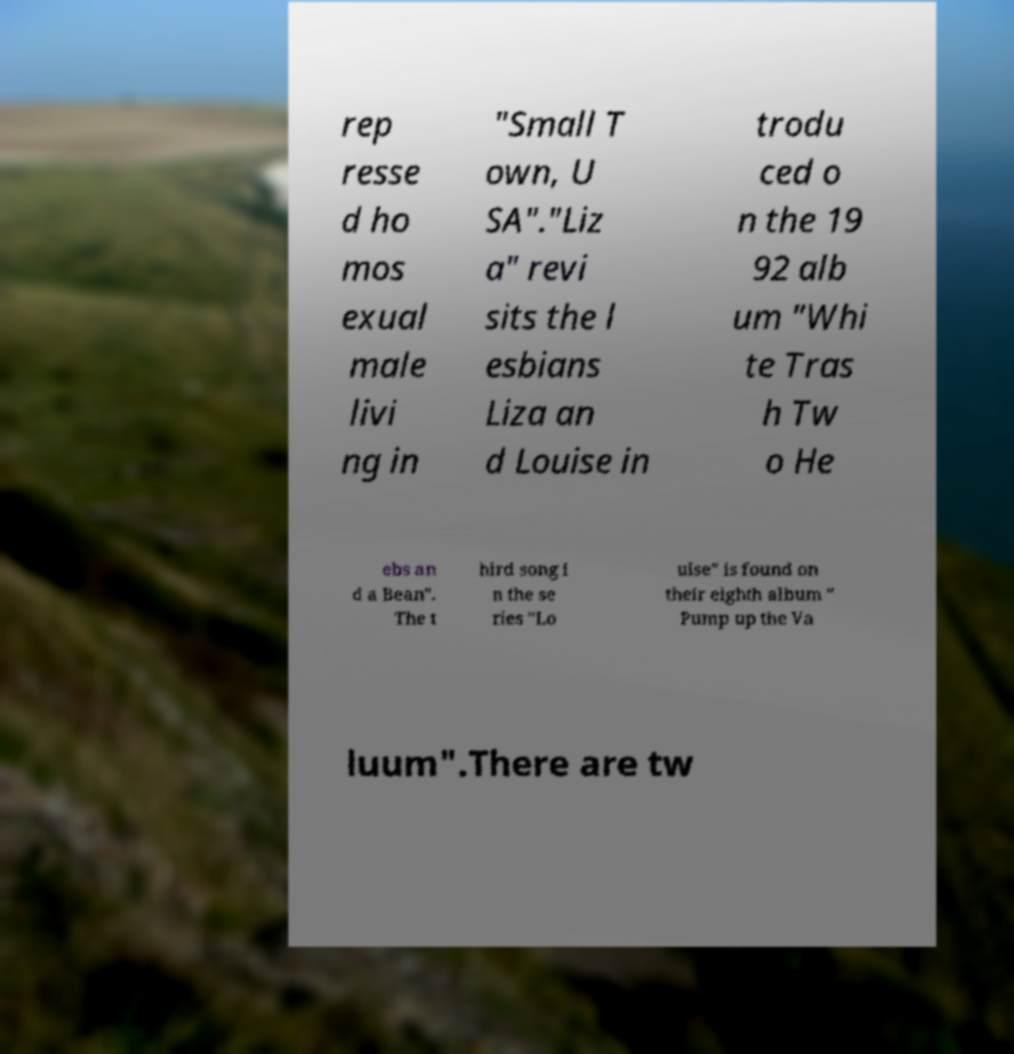Could you extract and type out the text from this image? rep resse d ho mos exual male livi ng in "Small T own, U SA"."Liz a" revi sits the l esbians Liza an d Louise in trodu ced o n the 19 92 alb um "Whi te Tras h Tw o He ebs an d a Bean". The t hird song i n the se ries "Lo uise" is found on their eighth album " Pump up the Va luum".There are tw 